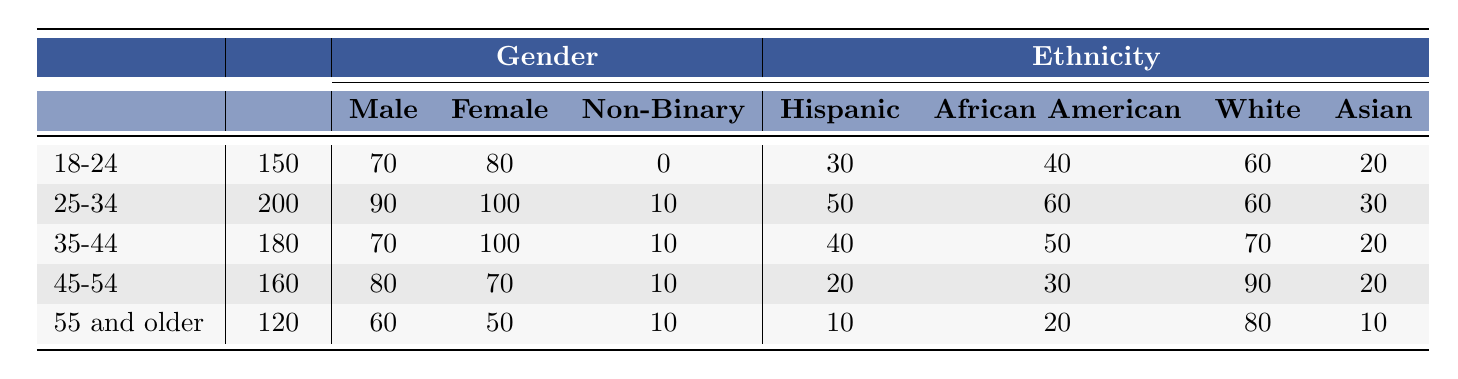What is the total number of participants in the 25-34 age group? The table indicates that the total participants in the 25-34 age group is 200.
Answer: 200 How many more female participants are there than male participants in the 18-24 age group? In the 18-24 age group, there are 80 female participants and 70 male participants. The difference is 80 - 70 = 10.
Answer: 10 What percentage of the total participants in the 35-44 age group are African American? The total participants in the 35-44 age group is 180, and there are 50 African American participants. To find the percentage, divide 50 by 180 and multiply by 100, which is approximately 27.78%.
Answer: 27.78% Is the number of male participants in the 45-54 age group greater than the number of Hispanic participants? In the 45-54 age group, there are 80 male participants and 20 Hispanic participants. Since 80 is greater than 20, the statement is true.
Answer: Yes What is the total number of participants across all age groups? The total participants across all age groups are calculated by adding the participants from each group: 150 + 200 + 180 + 160 + 120 = 810.
Answer: 810 Which age group has the highest number of female participants? From the table, the 25-34 age group has 100 female participants, which is the highest number compared to other age groups (80, 100, 70, and 50 respectively).
Answer: 25-34 How many non-binary participants are there in the 55 and older age group? The table lists that there are 10 non-binary participants in the 55 and older age group.
Answer: 10 What is the ratio of Hispanic participants to White participants in the 45-54 age group? In the 45-54 age group, there are 20 Hispanic participants and 90 White participants. The ratio is 20:90, which simplifies to 2:9.
Answer: 2:9 What percentage of the total participants in the 18-24 age group are Asian? In the 18-24 age group, there are 20 Asian participants out of 150 total participants. Calculating the percentage: (20/150) * 100 = 13.33%.
Answer: 13.33% How many total participants are there aged 35 and older? The age groups 35-44, 45-54, and 55 and older have a total of 180, 160, and 120 participants respectively. Summing these gives: 180 + 160 + 120 = 460.
Answer: 460 Does the 55 and older age group have the least total participants compared to other groups? The total participants in the 55 and older age group is 120, which is indeed the lowest when compared to the other age groups: 150, 200, 180, and 160 participants.
Answer: Yes 